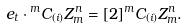Convert formula to latex. <formula><loc_0><loc_0><loc_500><loc_500>e _ { t } \cdot { ^ { m } C _ { ( i ) } } Z ^ { n } _ { m } = [ 2 ] { ^ { m } C _ { ( i ) } } Z ^ { n } _ { m } .</formula> 